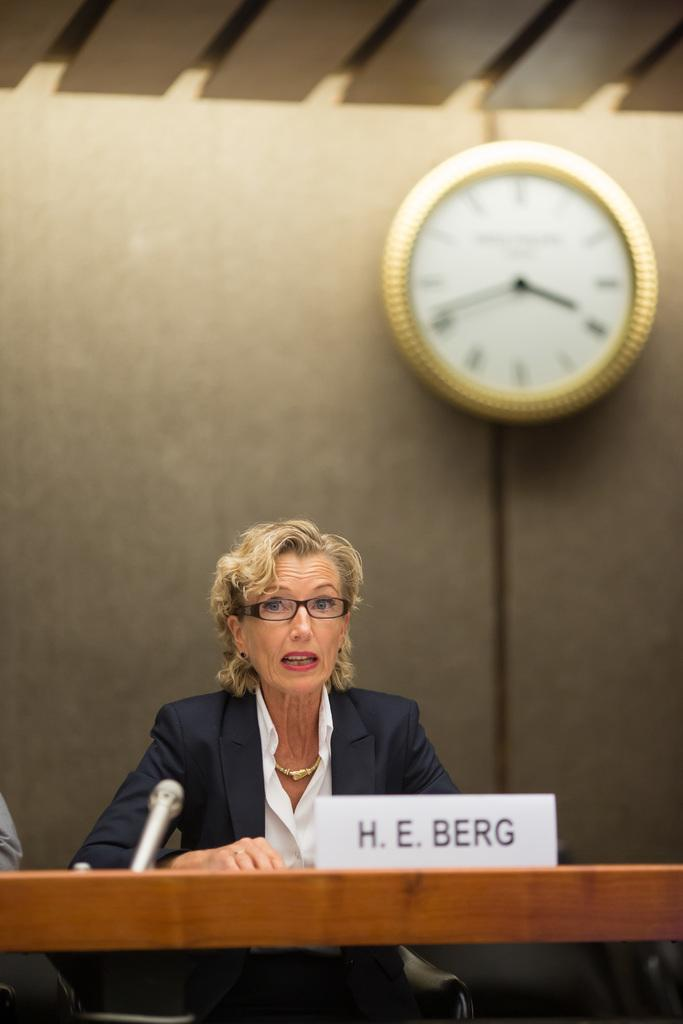<image>
Share a concise interpretation of the image provided. H E Berg sits behind a sign with her name on a lecture table 